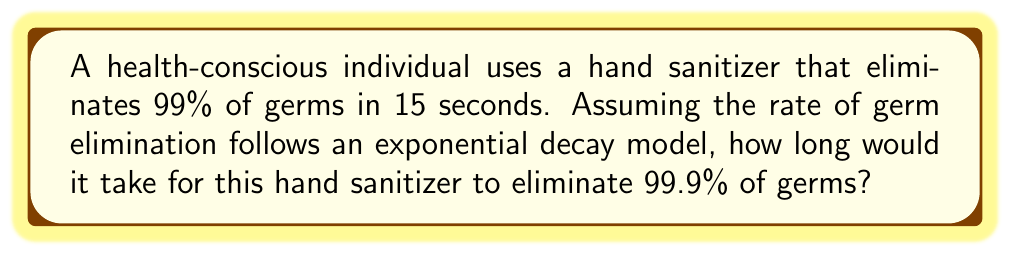Can you answer this question? Let's approach this step-by-step using logarithms:

1) Let $P(t)$ be the percentage of germs remaining after $t$ seconds.

2) The exponential decay model is given by:
   $P(t) = 100 \cdot (0.01)^{\frac{t}{15}}$

3) We want to find $t$ when $P(t) = 0.1$ (since 99.9% eliminated means 0.1% remaining):
   $0.1 = 100 \cdot (0.01)^{\frac{t}{15}}$

4) Divide both sides by 100:
   $0.001 = (0.01)^{\frac{t}{15}}$

5) Take the natural log of both sides:
   $\ln(0.001) = \ln((0.01)^{\frac{t}{15}})$

6) Use the logarithm property $\ln(a^b) = b\ln(a)$:
   $\ln(0.001) = \frac{t}{15} \ln(0.01)$

7) Solve for $t$:
   $t = 15 \cdot \frac{\ln(0.001)}{\ln(0.01)}$

8) Calculate:
   $t = 15 \cdot \frac{-6.90776}{-4.60517} \approx 22.5$ seconds

Therefore, it would take approximately 22.5 seconds to eliminate 99.9% of germs.
Answer: $22.5$ seconds 